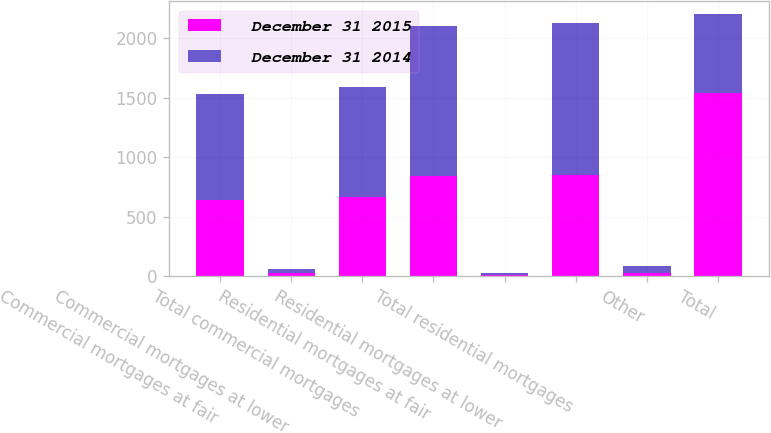<chart> <loc_0><loc_0><loc_500><loc_500><stacked_bar_chart><ecel><fcel>Commercial mortgages at fair<fcel>Commercial mortgages at lower<fcel>Total commercial mortgages<fcel>Residential mortgages at fair<fcel>Residential mortgages at lower<fcel>Total residential mortgages<fcel>Other<fcel>Total<nl><fcel>December 31 2015<fcel>641<fcel>27<fcel>668<fcel>843<fcel>7<fcel>850<fcel>22<fcel>1540<nl><fcel>December 31 2014<fcel>893<fcel>29<fcel>922<fcel>1261<fcel>18<fcel>1279<fcel>61<fcel>668<nl></chart> 